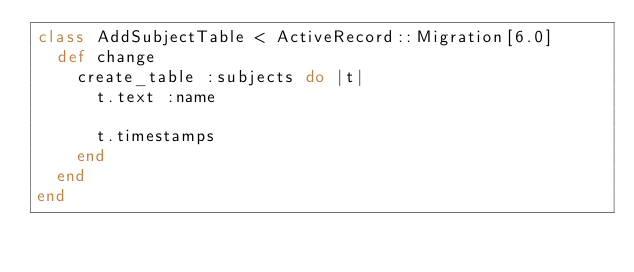<code> <loc_0><loc_0><loc_500><loc_500><_Ruby_>class AddSubjectTable < ActiveRecord::Migration[6.0]
  def change
    create_table :subjects do |t|
      t.text :name

      t.timestamps
    end
  end
end
</code> 